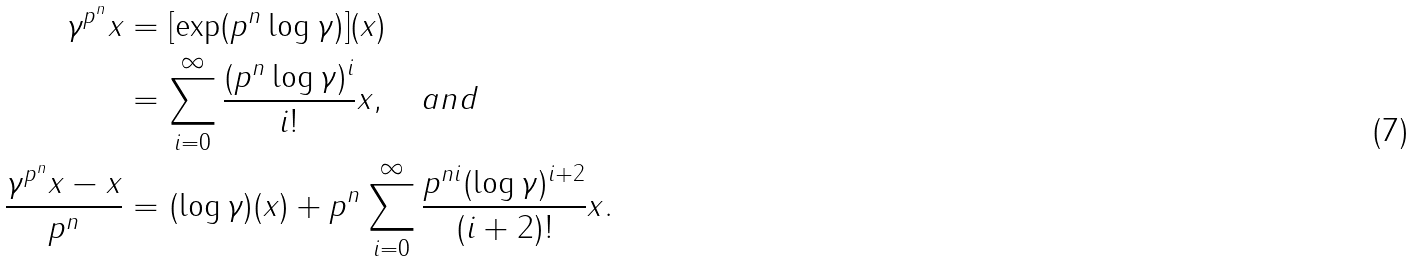<formula> <loc_0><loc_0><loc_500><loc_500>\gamma ^ { p ^ { n } } x & = [ \exp ( p ^ { n } \log \gamma ) ] ( x ) \\ & = \sum _ { i = 0 } ^ { \infty } \frac { ( p ^ { n } \log \gamma ) ^ { i } } { i ! } x , \quad a n d \\ \frac { \gamma ^ { p ^ { n } } x - x } { p ^ { n } } & = ( \log \gamma ) ( x ) + p ^ { n } \sum _ { i = 0 } ^ { \infty } \frac { p ^ { n i } ( \log \gamma ) ^ { i + 2 } } { ( i + 2 ) ! } x .</formula> 